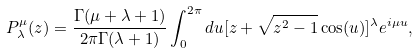<formula> <loc_0><loc_0><loc_500><loc_500>P ^ { \mu } _ { \lambda } ( z ) = \frac { \Gamma ( \mu + \lambda + 1 ) } { 2 \pi \Gamma ( \lambda + 1 ) } \int _ { 0 } ^ { 2 \pi } d u [ z + \sqrt { z ^ { 2 } - 1 } \cos ( u ) ] ^ { \lambda } e ^ { i \mu u } ,</formula> 